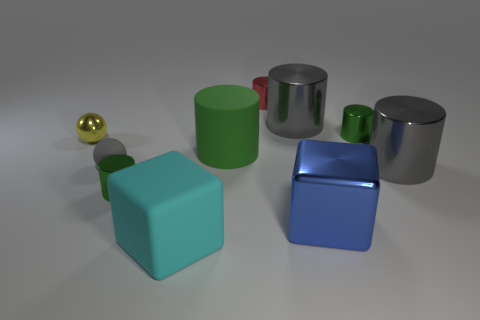Can you infer which object is the heaviest based on appearance? While it’s not possible to determine the exact weight without more information, if we assume the objects are made from materials with similar densities, the larger blue cube might be the heaviest due to its size. However, if the small golden sphere is made of a dense metal like gold, it could potentially weigh more than the larger objects made of lighter materials. 